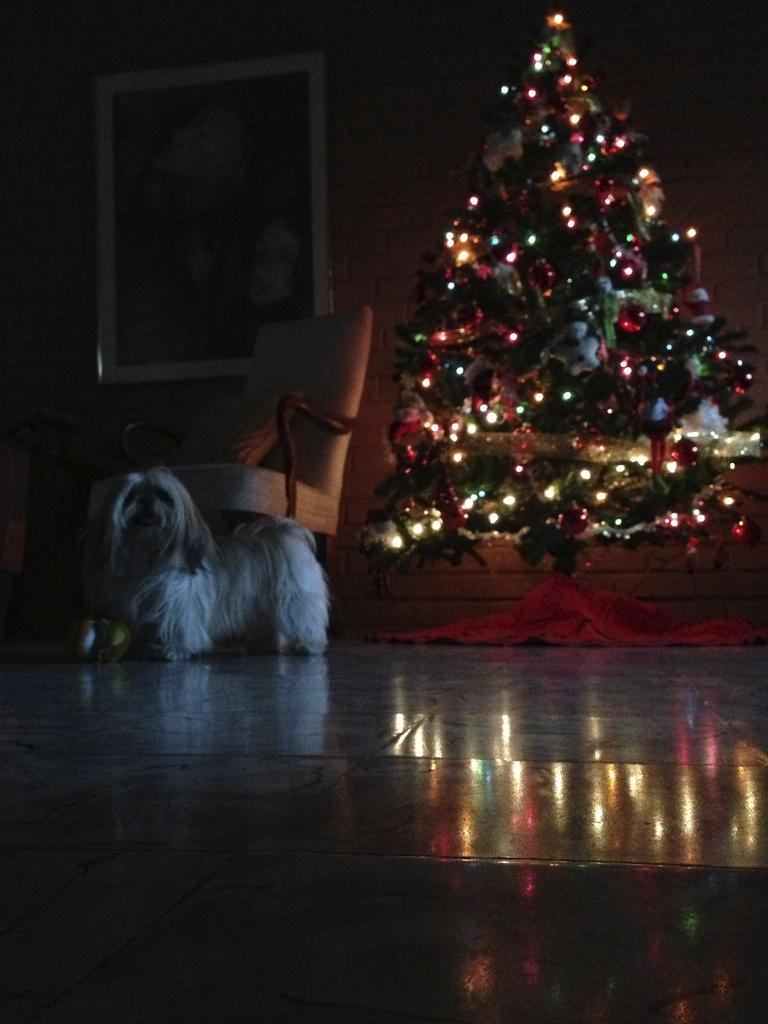What type of tree is in the image? There is a Christmas tree in the image. What decorations are on the Christmas tree? The Christmas tree has lights. What animal is on the floor in the image? There is a dog on the floor in the image. What type of furniture is in the background of the image? There is a chair in the background of the image. What is hanging on the wall in the background of the image? There is a photo frame on the wall in the background of the image. What type of meal is being prepared in the image? There is no indication of a meal being prepared in the image. 